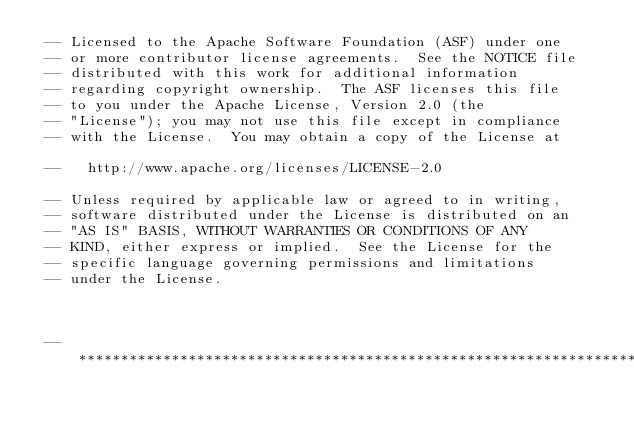Convert code to text. <code><loc_0><loc_0><loc_500><loc_500><_SQL_> -- Licensed to the Apache Software Foundation (ASF) under one
 -- or more contributor license agreements.  See the NOTICE file
 -- distributed with this work for additional information
 -- regarding copyright ownership.  The ASF licenses this file
 -- to you under the Apache License, Version 2.0 (the
 -- "License"); you may not use this file except in compliance
 -- with the License.  You may obtain a copy of the License at

 --   http://www.apache.org/licenses/LICENSE-2.0

 -- Unless required by applicable law or agreed to in writing,
 -- software distributed under the License is distributed on an
 -- "AS IS" BASIS, WITHOUT WARRANTIES OR CONDITIONS OF ANY
 -- KIND, either express or implied.  See the License for the
 -- specific language governing permissions and limitations
 -- under the License.



 -- ***********************************************************************************</code> 